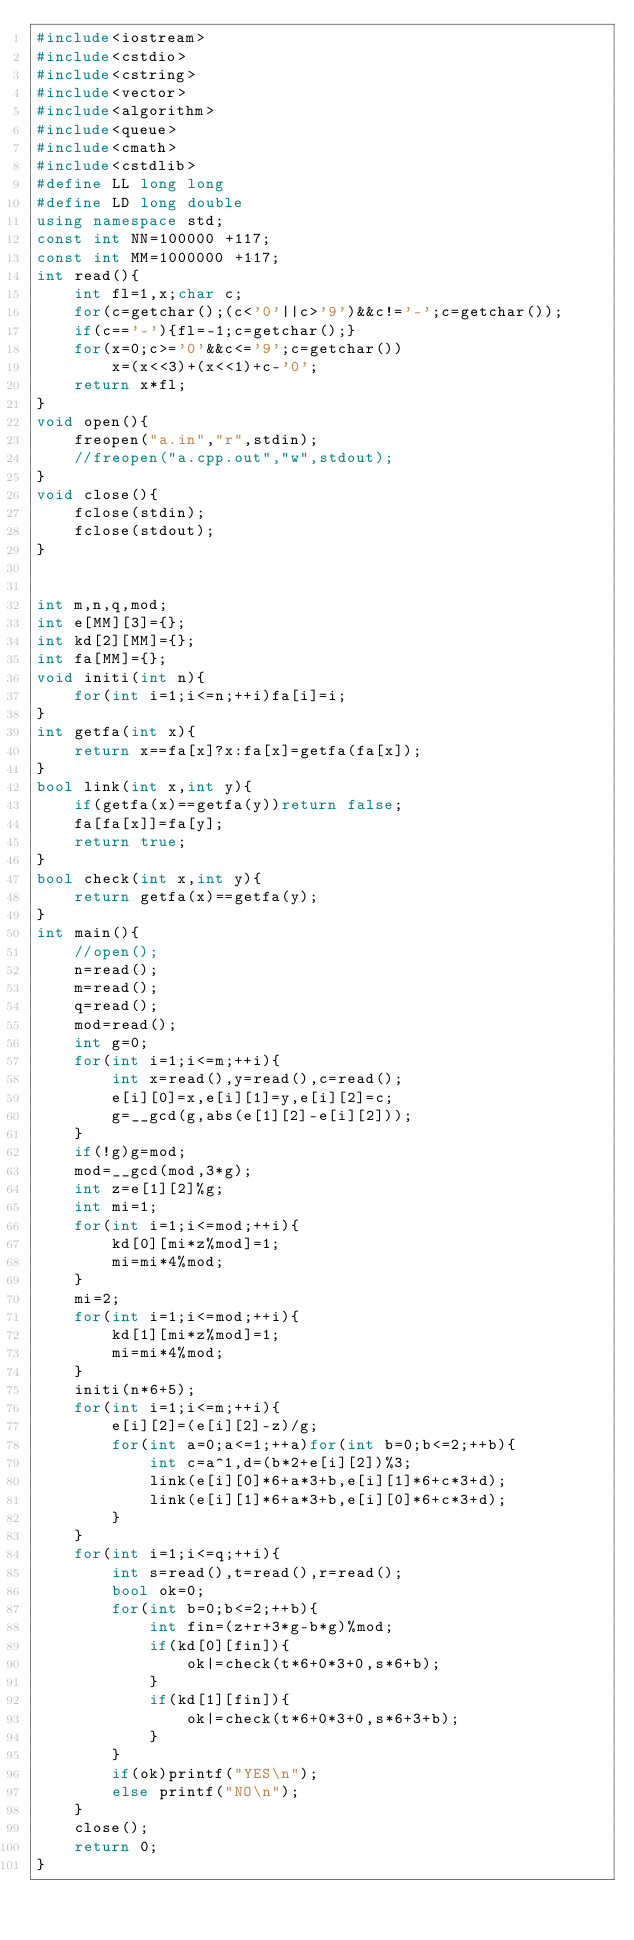Convert code to text. <code><loc_0><loc_0><loc_500><loc_500><_C++_>#include<iostream>
#include<cstdio>
#include<cstring>
#include<vector>
#include<algorithm>
#include<queue>
#include<cmath>
#include<cstdlib>
#define LL long long
#define LD long double
using namespace std;
const int NN=100000 +117;
const int MM=1000000 +117;
int read(){
	int fl=1,x;char c;
	for(c=getchar();(c<'0'||c>'9')&&c!='-';c=getchar());
	if(c=='-'){fl=-1;c=getchar();}
	for(x=0;c>='0'&&c<='9';c=getchar())
		x=(x<<3)+(x<<1)+c-'0';
	return x*fl;
}
void open(){
	freopen("a.in","r",stdin);
	//freopen("a.cpp.out","w",stdout);
}
void close(){
	fclose(stdin);
	fclose(stdout);
}


int m,n,q,mod;
int e[MM][3]={};
int kd[2][MM]={};
int fa[MM]={};
void initi(int n){
	for(int i=1;i<=n;++i)fa[i]=i;
}
int getfa(int x){
	return x==fa[x]?x:fa[x]=getfa(fa[x]);
}
bool link(int x,int y){
	if(getfa(x)==getfa(y))return false;
	fa[fa[x]]=fa[y];
	return true;
}
bool check(int x,int y){
	return getfa(x)==getfa(y);
}
int main(){
	//open();
	n=read();
	m=read();
	q=read();
	mod=read();
	int g=0;
	for(int i=1;i<=m;++i){
		int x=read(),y=read(),c=read();
		e[i][0]=x,e[i][1]=y,e[i][2]=c;
		g=__gcd(g,abs(e[1][2]-e[i][2]));
	}
	if(!g)g=mod;
	mod=__gcd(mod,3*g);
	int z=e[1][2]%g;
	int mi=1;
	for(int i=1;i<=mod;++i){
		kd[0][mi*z%mod]=1;
		mi=mi*4%mod;
	}
	mi=2;
	for(int i=1;i<=mod;++i){
		kd[1][mi*z%mod]=1;
		mi=mi*4%mod;
	}
	initi(n*6+5);
	for(int i=1;i<=m;++i){
		e[i][2]=(e[i][2]-z)/g;
		for(int a=0;a<=1;++a)for(int b=0;b<=2;++b){
			int c=a^1,d=(b*2+e[i][2])%3;
			link(e[i][0]*6+a*3+b,e[i][1]*6+c*3+d);
			link(e[i][1]*6+a*3+b,e[i][0]*6+c*3+d);
		}
	}
	for(int i=1;i<=q;++i){
		int s=read(),t=read(),r=read();
		bool ok=0;
		for(int b=0;b<=2;++b){
			int fin=(z+r+3*g-b*g)%mod;
			if(kd[0][fin]){
				ok|=check(t*6+0*3+0,s*6+b);
			}
			if(kd[1][fin]){
				ok|=check(t*6+0*3+0,s*6+3+b);
			}
		}
		if(ok)printf("YES\n");
		else printf("NO\n");
	}
	close();
	return 0;
}</code> 